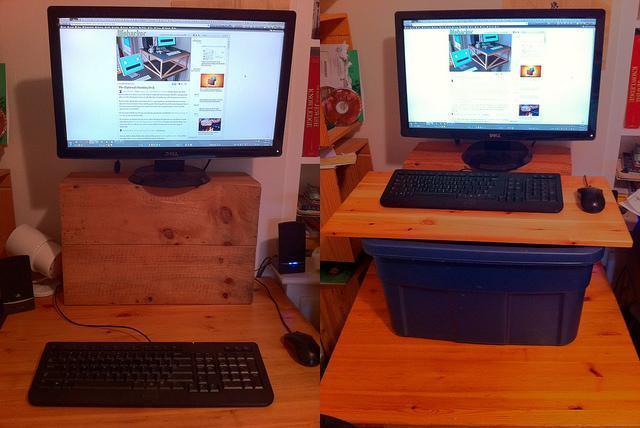How many keyboards are visible?
Give a very brief answer. 2. How many tvs are in the photo?
Give a very brief answer. 2. How many people are wearing black jacket?
Give a very brief answer. 0. 